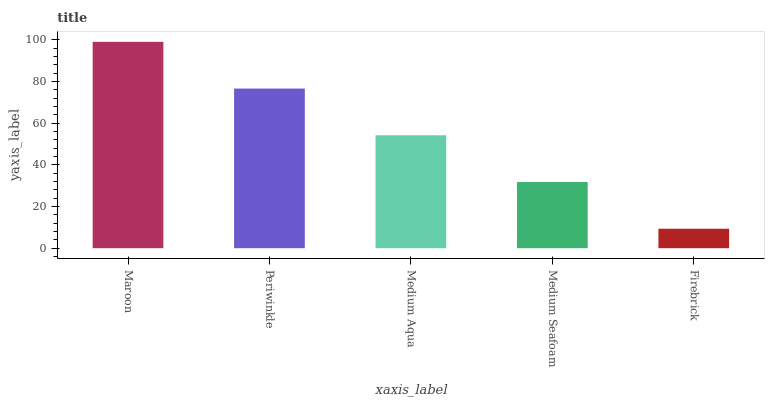Is Firebrick the minimum?
Answer yes or no. Yes. Is Maroon the maximum?
Answer yes or no. Yes. Is Periwinkle the minimum?
Answer yes or no. No. Is Periwinkle the maximum?
Answer yes or no. No. Is Maroon greater than Periwinkle?
Answer yes or no. Yes. Is Periwinkle less than Maroon?
Answer yes or no. Yes. Is Periwinkle greater than Maroon?
Answer yes or no. No. Is Maroon less than Periwinkle?
Answer yes or no. No. Is Medium Aqua the high median?
Answer yes or no. Yes. Is Medium Aqua the low median?
Answer yes or no. Yes. Is Medium Seafoam the high median?
Answer yes or no. No. Is Periwinkle the low median?
Answer yes or no. No. 